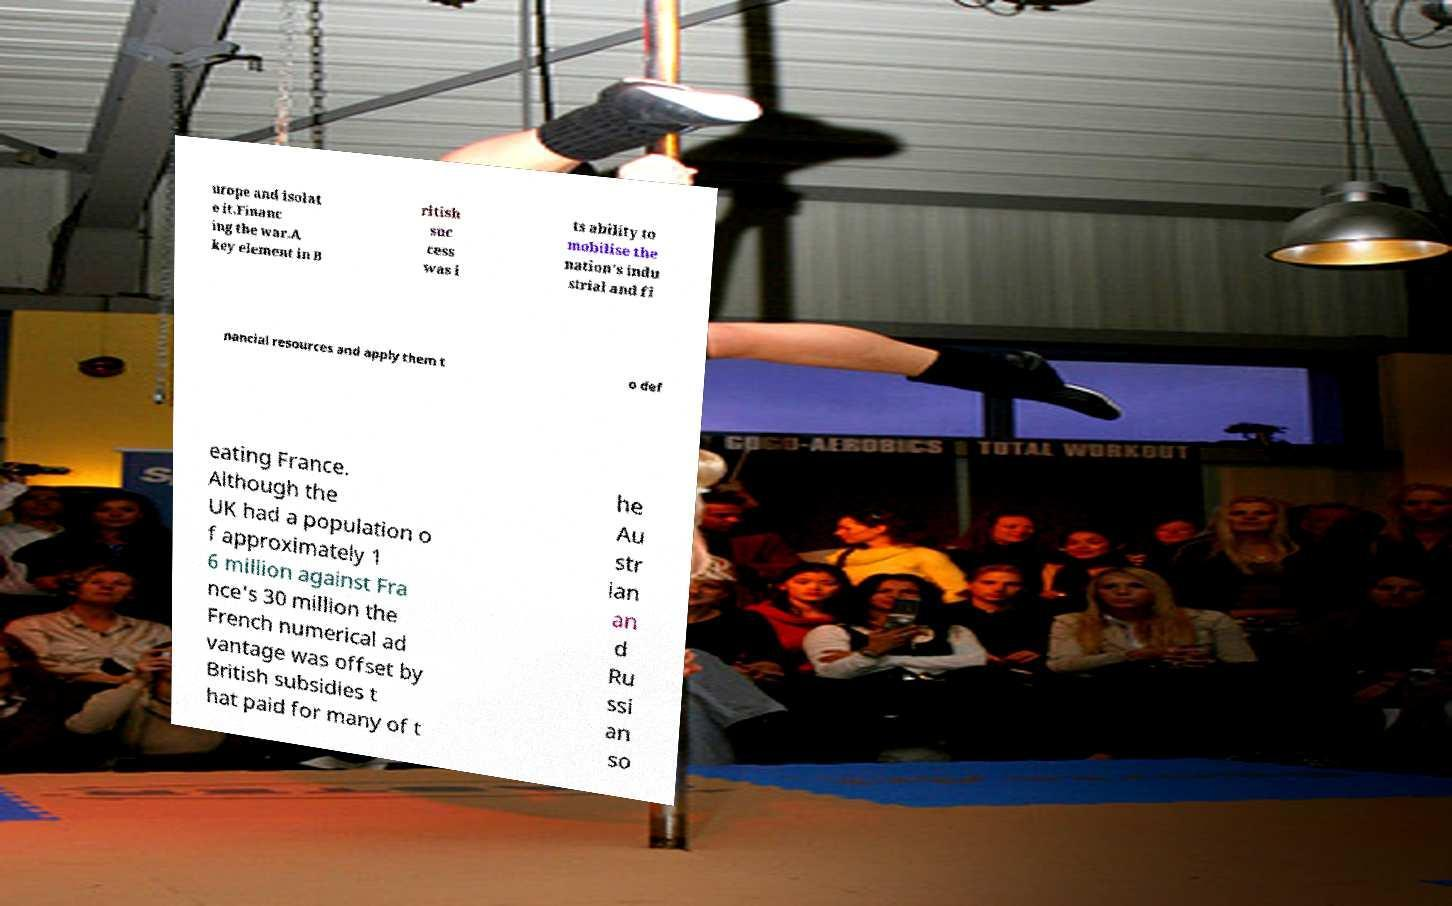Could you assist in decoding the text presented in this image and type it out clearly? urope and isolat e it.Financ ing the war.A key element in B ritish suc cess was i ts ability to mobilise the nation's indu strial and fi nancial resources and apply them t o def eating France. Although the UK had a population o f approximately 1 6 million against Fra nce's 30 million the French numerical ad vantage was offset by British subsidies t hat paid for many of t he Au str ian an d Ru ssi an so 